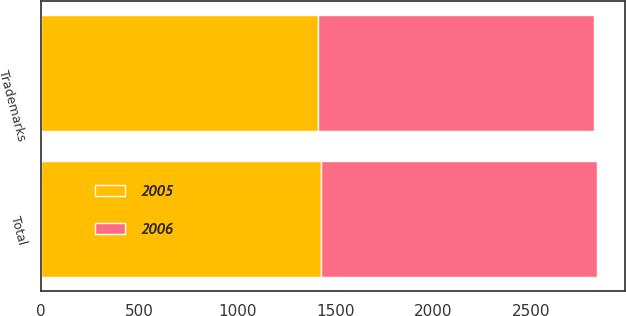Convert chart to OTSL. <chart><loc_0><loc_0><loc_500><loc_500><stacked_bar_chart><ecel><fcel>Trademarks<fcel>Total<nl><fcel>2006<fcel>1410.2<fcel>1410.2<nl><fcel>2005<fcel>1410.2<fcel>1427.2<nl></chart> 